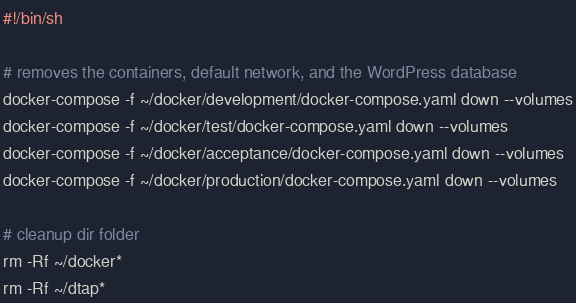Convert code to text. <code><loc_0><loc_0><loc_500><loc_500><_Bash_>#!/bin/sh

# removes the containers, default network, and the WordPress database 
docker-compose -f ~/docker/development/docker-compose.yaml down --volumes
docker-compose -f ~/docker/test/docker-compose.yaml down --volumes
docker-compose -f ~/docker/acceptance/docker-compose.yaml down --volumes
docker-compose -f ~/docker/production/docker-compose.yaml down --volumes

# cleanup dir folder
rm -Rf ~/docker*
rm -Rf ~/dtap*
</code> 